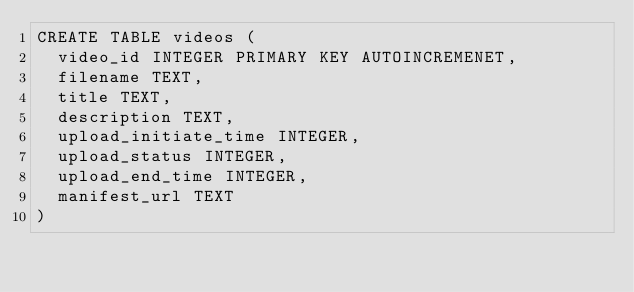Convert code to text. <code><loc_0><loc_0><loc_500><loc_500><_SQL_>CREATE TABLE videos (
	video_id INTEGER PRIMARY KEY AUTOINCREMENET,
	filename TEXT,
	title TEXT,
	description TEXT,
	upload_initiate_time INTEGER,
	upload_status INTEGER,
	upload_end_time INTEGER,
	manifest_url TEXT
)</code> 